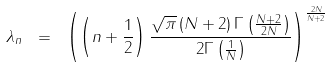Convert formula to latex. <formula><loc_0><loc_0><loc_500><loc_500>\lambda _ { n } \ = \ \left ( \left ( n + \frac { 1 } { 2 } \right ) \frac { { \sqrt { \pi } } \left ( N + 2 \right ) \Gamma \left ( \frac { N + 2 } { 2 N } \right ) } { 2 \Gamma \left ( \frac { 1 } { N } \right ) } \right ) ^ { \frac { 2 N } { N + 2 } }</formula> 